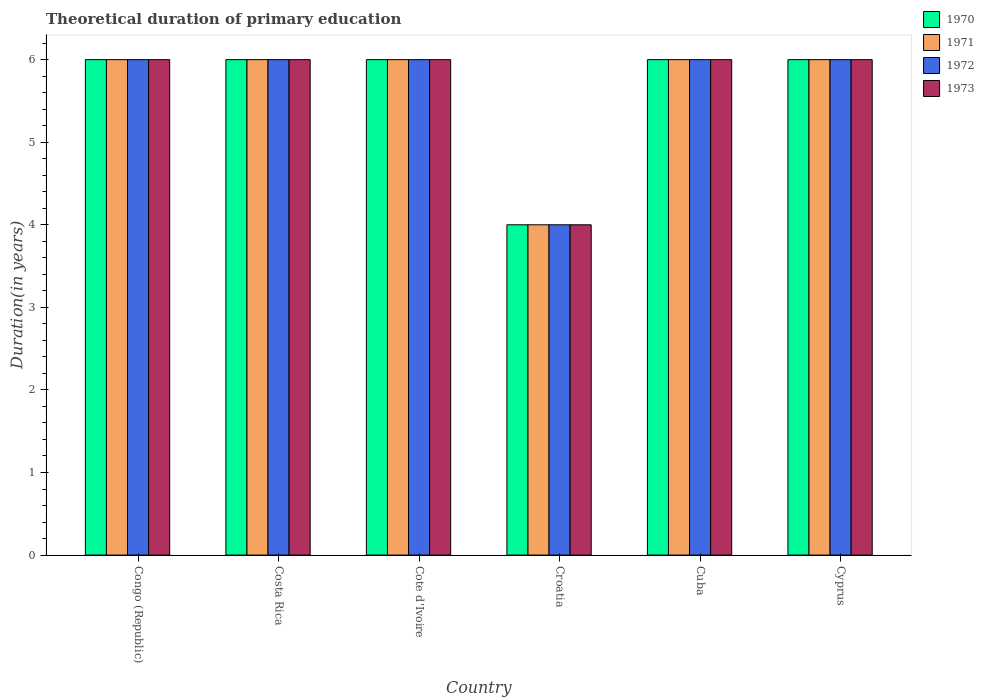How many different coloured bars are there?
Provide a short and direct response. 4. How many groups of bars are there?
Provide a short and direct response. 6. Are the number of bars on each tick of the X-axis equal?
Make the answer very short. Yes. How many bars are there on the 1st tick from the left?
Make the answer very short. 4. How many bars are there on the 2nd tick from the right?
Offer a terse response. 4. What is the label of the 3rd group of bars from the left?
Provide a succinct answer. Cote d'Ivoire. In how many cases, is the number of bars for a given country not equal to the number of legend labels?
Provide a succinct answer. 0. Across all countries, what is the minimum total theoretical duration of primary education in 1972?
Offer a very short reply. 4. In which country was the total theoretical duration of primary education in 1970 maximum?
Offer a terse response. Congo (Republic). In which country was the total theoretical duration of primary education in 1970 minimum?
Provide a short and direct response. Croatia. What is the total total theoretical duration of primary education in 1973 in the graph?
Provide a short and direct response. 34. What is the difference between the total theoretical duration of primary education in 1971 in Costa Rica and that in Cote d'Ivoire?
Provide a succinct answer. 0. What is the average total theoretical duration of primary education in 1973 per country?
Give a very brief answer. 5.67. What is the difference between the total theoretical duration of primary education of/in 1972 and total theoretical duration of primary education of/in 1970 in Croatia?
Offer a very short reply. 0. Is the total theoretical duration of primary education in 1973 in Costa Rica less than that in Croatia?
Your response must be concise. No. What is the difference between the highest and the lowest total theoretical duration of primary education in 1970?
Give a very brief answer. 2. In how many countries, is the total theoretical duration of primary education in 1973 greater than the average total theoretical duration of primary education in 1973 taken over all countries?
Your response must be concise. 5. Is the sum of the total theoretical duration of primary education in 1971 in Congo (Republic) and Cuba greater than the maximum total theoretical duration of primary education in 1973 across all countries?
Ensure brevity in your answer.  Yes. What does the 2nd bar from the left in Costa Rica represents?
Your answer should be very brief. 1971. How many bars are there?
Give a very brief answer. 24. How many countries are there in the graph?
Your answer should be very brief. 6. Does the graph contain any zero values?
Provide a short and direct response. No. How many legend labels are there?
Give a very brief answer. 4. How are the legend labels stacked?
Keep it short and to the point. Vertical. What is the title of the graph?
Your response must be concise. Theoretical duration of primary education. What is the label or title of the X-axis?
Make the answer very short. Country. What is the label or title of the Y-axis?
Keep it short and to the point. Duration(in years). What is the Duration(in years) of 1971 in Congo (Republic)?
Your answer should be compact. 6. What is the Duration(in years) of 1973 in Congo (Republic)?
Ensure brevity in your answer.  6. What is the Duration(in years) of 1970 in Costa Rica?
Keep it short and to the point. 6. What is the Duration(in years) of 1970 in Cote d'Ivoire?
Provide a succinct answer. 6. What is the Duration(in years) of 1971 in Cote d'Ivoire?
Provide a short and direct response. 6. What is the Duration(in years) in 1973 in Cote d'Ivoire?
Keep it short and to the point. 6. Across all countries, what is the maximum Duration(in years) of 1973?
Make the answer very short. 6. Across all countries, what is the minimum Duration(in years) of 1972?
Offer a terse response. 4. Across all countries, what is the minimum Duration(in years) in 1973?
Provide a short and direct response. 4. What is the total Duration(in years) in 1970 in the graph?
Your response must be concise. 34. What is the total Duration(in years) of 1971 in the graph?
Provide a succinct answer. 34. What is the total Duration(in years) of 1972 in the graph?
Provide a succinct answer. 34. What is the total Duration(in years) of 1973 in the graph?
Keep it short and to the point. 34. What is the difference between the Duration(in years) in 1971 in Congo (Republic) and that in Costa Rica?
Your response must be concise. 0. What is the difference between the Duration(in years) of 1972 in Congo (Republic) and that in Costa Rica?
Provide a succinct answer. 0. What is the difference between the Duration(in years) of 1970 in Congo (Republic) and that in Cote d'Ivoire?
Offer a terse response. 0. What is the difference between the Duration(in years) in 1971 in Congo (Republic) and that in Cote d'Ivoire?
Offer a very short reply. 0. What is the difference between the Duration(in years) in 1972 in Congo (Republic) and that in Cote d'Ivoire?
Keep it short and to the point. 0. What is the difference between the Duration(in years) in 1970 in Congo (Republic) and that in Croatia?
Provide a short and direct response. 2. What is the difference between the Duration(in years) in 1971 in Congo (Republic) and that in Croatia?
Make the answer very short. 2. What is the difference between the Duration(in years) in 1971 in Congo (Republic) and that in Cuba?
Offer a very short reply. 0. What is the difference between the Duration(in years) in 1972 in Congo (Republic) and that in Cuba?
Keep it short and to the point. 0. What is the difference between the Duration(in years) in 1973 in Congo (Republic) and that in Cuba?
Offer a very short reply. 0. What is the difference between the Duration(in years) of 1973 in Congo (Republic) and that in Cyprus?
Ensure brevity in your answer.  0. What is the difference between the Duration(in years) in 1970 in Costa Rica and that in Cote d'Ivoire?
Make the answer very short. 0. What is the difference between the Duration(in years) in 1971 in Costa Rica and that in Cote d'Ivoire?
Ensure brevity in your answer.  0. What is the difference between the Duration(in years) in 1972 in Costa Rica and that in Cote d'Ivoire?
Keep it short and to the point. 0. What is the difference between the Duration(in years) in 1973 in Costa Rica and that in Cote d'Ivoire?
Your answer should be compact. 0. What is the difference between the Duration(in years) in 1970 in Costa Rica and that in Croatia?
Your response must be concise. 2. What is the difference between the Duration(in years) of 1971 in Costa Rica and that in Croatia?
Offer a very short reply. 2. What is the difference between the Duration(in years) of 1973 in Costa Rica and that in Croatia?
Your answer should be very brief. 2. What is the difference between the Duration(in years) in 1971 in Costa Rica and that in Cuba?
Provide a short and direct response. 0. What is the difference between the Duration(in years) of 1972 in Costa Rica and that in Cuba?
Offer a very short reply. 0. What is the difference between the Duration(in years) in 1973 in Costa Rica and that in Cuba?
Provide a succinct answer. 0. What is the difference between the Duration(in years) of 1970 in Costa Rica and that in Cyprus?
Your answer should be compact. 0. What is the difference between the Duration(in years) of 1973 in Costa Rica and that in Cyprus?
Make the answer very short. 0. What is the difference between the Duration(in years) of 1971 in Cote d'Ivoire and that in Croatia?
Provide a succinct answer. 2. What is the difference between the Duration(in years) of 1972 in Cote d'Ivoire and that in Croatia?
Keep it short and to the point. 2. What is the difference between the Duration(in years) in 1970 in Cote d'Ivoire and that in Cuba?
Give a very brief answer. 0. What is the difference between the Duration(in years) of 1970 in Cote d'Ivoire and that in Cyprus?
Provide a succinct answer. 0. What is the difference between the Duration(in years) in 1971 in Cote d'Ivoire and that in Cyprus?
Keep it short and to the point. 0. What is the difference between the Duration(in years) in 1972 in Cote d'Ivoire and that in Cyprus?
Offer a terse response. 0. What is the difference between the Duration(in years) in 1970 in Croatia and that in Cuba?
Your answer should be compact. -2. What is the difference between the Duration(in years) of 1971 in Croatia and that in Cuba?
Give a very brief answer. -2. What is the difference between the Duration(in years) in 1973 in Croatia and that in Cuba?
Offer a terse response. -2. What is the difference between the Duration(in years) of 1971 in Croatia and that in Cyprus?
Offer a terse response. -2. What is the difference between the Duration(in years) in 1972 in Croatia and that in Cyprus?
Offer a very short reply. -2. What is the difference between the Duration(in years) in 1973 in Croatia and that in Cyprus?
Keep it short and to the point. -2. What is the difference between the Duration(in years) of 1970 in Cuba and that in Cyprus?
Offer a terse response. 0. What is the difference between the Duration(in years) of 1971 in Cuba and that in Cyprus?
Your response must be concise. 0. What is the difference between the Duration(in years) of 1972 in Cuba and that in Cyprus?
Offer a terse response. 0. What is the difference between the Duration(in years) in 1970 in Congo (Republic) and the Duration(in years) in 1971 in Costa Rica?
Your answer should be very brief. 0. What is the difference between the Duration(in years) in 1970 in Congo (Republic) and the Duration(in years) in 1972 in Costa Rica?
Give a very brief answer. 0. What is the difference between the Duration(in years) of 1970 in Congo (Republic) and the Duration(in years) of 1973 in Costa Rica?
Offer a terse response. 0. What is the difference between the Duration(in years) in 1971 in Congo (Republic) and the Duration(in years) in 1972 in Costa Rica?
Ensure brevity in your answer.  0. What is the difference between the Duration(in years) in 1970 in Congo (Republic) and the Duration(in years) in 1973 in Cote d'Ivoire?
Provide a succinct answer. 0. What is the difference between the Duration(in years) of 1971 in Congo (Republic) and the Duration(in years) of 1972 in Cote d'Ivoire?
Offer a terse response. 0. What is the difference between the Duration(in years) in 1971 in Congo (Republic) and the Duration(in years) in 1973 in Cote d'Ivoire?
Make the answer very short. 0. What is the difference between the Duration(in years) in 1972 in Congo (Republic) and the Duration(in years) in 1973 in Cote d'Ivoire?
Provide a short and direct response. 0. What is the difference between the Duration(in years) in 1970 in Congo (Republic) and the Duration(in years) in 1972 in Croatia?
Your answer should be compact. 2. What is the difference between the Duration(in years) of 1970 in Congo (Republic) and the Duration(in years) of 1973 in Croatia?
Keep it short and to the point. 2. What is the difference between the Duration(in years) of 1971 in Congo (Republic) and the Duration(in years) of 1973 in Croatia?
Your answer should be compact. 2. What is the difference between the Duration(in years) in 1970 in Congo (Republic) and the Duration(in years) in 1971 in Cuba?
Your response must be concise. 0. What is the difference between the Duration(in years) in 1970 in Congo (Republic) and the Duration(in years) in 1973 in Cuba?
Offer a very short reply. 0. What is the difference between the Duration(in years) in 1971 in Congo (Republic) and the Duration(in years) in 1972 in Cuba?
Make the answer very short. 0. What is the difference between the Duration(in years) of 1970 in Congo (Republic) and the Duration(in years) of 1973 in Cyprus?
Your answer should be very brief. 0. What is the difference between the Duration(in years) in 1972 in Congo (Republic) and the Duration(in years) in 1973 in Cyprus?
Provide a short and direct response. 0. What is the difference between the Duration(in years) in 1970 in Costa Rica and the Duration(in years) in 1971 in Cote d'Ivoire?
Your answer should be very brief. 0. What is the difference between the Duration(in years) of 1971 in Costa Rica and the Duration(in years) of 1972 in Cote d'Ivoire?
Give a very brief answer. 0. What is the difference between the Duration(in years) in 1970 in Costa Rica and the Duration(in years) in 1972 in Croatia?
Provide a short and direct response. 2. What is the difference between the Duration(in years) of 1971 in Costa Rica and the Duration(in years) of 1972 in Croatia?
Your answer should be compact. 2. What is the difference between the Duration(in years) of 1972 in Costa Rica and the Duration(in years) of 1973 in Croatia?
Make the answer very short. 2. What is the difference between the Duration(in years) in 1970 in Costa Rica and the Duration(in years) in 1971 in Cuba?
Ensure brevity in your answer.  0. What is the difference between the Duration(in years) in 1970 in Costa Rica and the Duration(in years) in 1972 in Cuba?
Your response must be concise. 0. What is the difference between the Duration(in years) of 1970 in Costa Rica and the Duration(in years) of 1973 in Cuba?
Your answer should be compact. 0. What is the difference between the Duration(in years) in 1972 in Costa Rica and the Duration(in years) in 1973 in Cuba?
Provide a short and direct response. 0. What is the difference between the Duration(in years) in 1970 in Costa Rica and the Duration(in years) in 1972 in Cyprus?
Keep it short and to the point. 0. What is the difference between the Duration(in years) of 1970 in Costa Rica and the Duration(in years) of 1973 in Cyprus?
Keep it short and to the point. 0. What is the difference between the Duration(in years) in 1971 in Costa Rica and the Duration(in years) in 1972 in Cyprus?
Ensure brevity in your answer.  0. What is the difference between the Duration(in years) in 1971 in Costa Rica and the Duration(in years) in 1973 in Cyprus?
Your answer should be compact. 0. What is the difference between the Duration(in years) in 1970 in Cote d'Ivoire and the Duration(in years) in 1972 in Croatia?
Your answer should be very brief. 2. What is the difference between the Duration(in years) of 1970 in Cote d'Ivoire and the Duration(in years) of 1973 in Croatia?
Provide a short and direct response. 2. What is the difference between the Duration(in years) of 1971 in Cote d'Ivoire and the Duration(in years) of 1973 in Croatia?
Offer a terse response. 2. What is the difference between the Duration(in years) of 1970 in Cote d'Ivoire and the Duration(in years) of 1971 in Cuba?
Give a very brief answer. 0. What is the difference between the Duration(in years) of 1971 in Cote d'Ivoire and the Duration(in years) of 1972 in Cuba?
Make the answer very short. 0. What is the difference between the Duration(in years) of 1971 in Cote d'Ivoire and the Duration(in years) of 1973 in Cuba?
Provide a short and direct response. 0. What is the difference between the Duration(in years) in 1972 in Cote d'Ivoire and the Duration(in years) in 1973 in Cuba?
Provide a short and direct response. 0. What is the difference between the Duration(in years) of 1970 in Cote d'Ivoire and the Duration(in years) of 1972 in Cyprus?
Offer a terse response. 0. What is the difference between the Duration(in years) in 1970 in Cote d'Ivoire and the Duration(in years) in 1973 in Cyprus?
Your response must be concise. 0. What is the difference between the Duration(in years) of 1971 in Cote d'Ivoire and the Duration(in years) of 1972 in Cyprus?
Provide a succinct answer. 0. What is the difference between the Duration(in years) of 1972 in Cote d'Ivoire and the Duration(in years) of 1973 in Cyprus?
Your response must be concise. 0. What is the difference between the Duration(in years) in 1970 in Croatia and the Duration(in years) in 1971 in Cuba?
Your response must be concise. -2. What is the difference between the Duration(in years) in 1970 in Croatia and the Duration(in years) in 1972 in Cuba?
Offer a very short reply. -2. What is the difference between the Duration(in years) in 1970 in Croatia and the Duration(in years) in 1973 in Cuba?
Ensure brevity in your answer.  -2. What is the difference between the Duration(in years) of 1972 in Croatia and the Duration(in years) of 1973 in Cuba?
Your answer should be compact. -2. What is the difference between the Duration(in years) in 1970 in Croatia and the Duration(in years) in 1973 in Cyprus?
Give a very brief answer. -2. What is the difference between the Duration(in years) in 1972 in Croatia and the Duration(in years) in 1973 in Cyprus?
Provide a short and direct response. -2. What is the difference between the Duration(in years) of 1970 in Cuba and the Duration(in years) of 1972 in Cyprus?
Offer a terse response. 0. What is the difference between the Duration(in years) in 1971 in Cuba and the Duration(in years) in 1973 in Cyprus?
Make the answer very short. 0. What is the difference between the Duration(in years) of 1972 in Cuba and the Duration(in years) of 1973 in Cyprus?
Make the answer very short. 0. What is the average Duration(in years) in 1970 per country?
Give a very brief answer. 5.67. What is the average Duration(in years) of 1971 per country?
Make the answer very short. 5.67. What is the average Duration(in years) in 1972 per country?
Offer a very short reply. 5.67. What is the average Duration(in years) in 1973 per country?
Ensure brevity in your answer.  5.67. What is the difference between the Duration(in years) in 1970 and Duration(in years) in 1971 in Congo (Republic)?
Your answer should be very brief. 0. What is the difference between the Duration(in years) in 1970 and Duration(in years) in 1972 in Congo (Republic)?
Offer a terse response. 0. What is the difference between the Duration(in years) in 1971 and Duration(in years) in 1972 in Congo (Republic)?
Offer a very short reply. 0. What is the difference between the Duration(in years) in 1971 and Duration(in years) in 1973 in Congo (Republic)?
Your response must be concise. 0. What is the difference between the Duration(in years) in 1972 and Duration(in years) in 1973 in Congo (Republic)?
Offer a very short reply. 0. What is the difference between the Duration(in years) in 1970 and Duration(in years) in 1973 in Costa Rica?
Make the answer very short. 0. What is the difference between the Duration(in years) in 1971 and Duration(in years) in 1973 in Costa Rica?
Make the answer very short. 0. What is the difference between the Duration(in years) of 1970 and Duration(in years) of 1973 in Cote d'Ivoire?
Your answer should be compact. 0. What is the difference between the Duration(in years) of 1971 and Duration(in years) of 1972 in Cote d'Ivoire?
Offer a terse response. 0. What is the difference between the Duration(in years) of 1971 and Duration(in years) of 1973 in Cote d'Ivoire?
Your answer should be compact. 0. What is the difference between the Duration(in years) of 1972 and Duration(in years) of 1973 in Cote d'Ivoire?
Offer a very short reply. 0. What is the difference between the Duration(in years) of 1970 and Duration(in years) of 1971 in Croatia?
Your answer should be compact. 0. What is the difference between the Duration(in years) of 1970 and Duration(in years) of 1973 in Croatia?
Offer a very short reply. 0. What is the difference between the Duration(in years) of 1970 and Duration(in years) of 1971 in Cuba?
Provide a succinct answer. 0. What is the difference between the Duration(in years) in 1970 and Duration(in years) in 1972 in Cuba?
Offer a very short reply. 0. What is the difference between the Duration(in years) of 1970 and Duration(in years) of 1973 in Cuba?
Make the answer very short. 0. What is the difference between the Duration(in years) in 1970 and Duration(in years) in 1972 in Cyprus?
Make the answer very short. 0. What is the difference between the Duration(in years) in 1971 and Duration(in years) in 1972 in Cyprus?
Offer a terse response. 0. What is the difference between the Duration(in years) in 1971 and Duration(in years) in 1973 in Cyprus?
Your response must be concise. 0. What is the difference between the Duration(in years) in 1972 and Duration(in years) in 1973 in Cyprus?
Keep it short and to the point. 0. What is the ratio of the Duration(in years) in 1970 in Congo (Republic) to that in Costa Rica?
Offer a terse response. 1. What is the ratio of the Duration(in years) in 1972 in Congo (Republic) to that in Costa Rica?
Your answer should be compact. 1. What is the ratio of the Duration(in years) in 1973 in Congo (Republic) to that in Costa Rica?
Provide a succinct answer. 1. What is the ratio of the Duration(in years) of 1971 in Congo (Republic) to that in Cote d'Ivoire?
Make the answer very short. 1. What is the ratio of the Duration(in years) of 1970 in Congo (Republic) to that in Croatia?
Your response must be concise. 1.5. What is the ratio of the Duration(in years) in 1973 in Congo (Republic) to that in Croatia?
Your answer should be very brief. 1.5. What is the ratio of the Duration(in years) in 1970 in Congo (Republic) to that in Cuba?
Offer a terse response. 1. What is the ratio of the Duration(in years) of 1971 in Congo (Republic) to that in Cuba?
Keep it short and to the point. 1. What is the ratio of the Duration(in years) of 1972 in Congo (Republic) to that in Cuba?
Keep it short and to the point. 1. What is the ratio of the Duration(in years) in 1973 in Congo (Republic) to that in Cuba?
Provide a succinct answer. 1. What is the ratio of the Duration(in years) in 1973 in Congo (Republic) to that in Cyprus?
Make the answer very short. 1. What is the ratio of the Duration(in years) in 1970 in Costa Rica to that in Cote d'Ivoire?
Give a very brief answer. 1. What is the ratio of the Duration(in years) of 1971 in Costa Rica to that in Cote d'Ivoire?
Make the answer very short. 1. What is the ratio of the Duration(in years) of 1971 in Costa Rica to that in Croatia?
Your response must be concise. 1.5. What is the ratio of the Duration(in years) in 1973 in Costa Rica to that in Croatia?
Offer a very short reply. 1.5. What is the ratio of the Duration(in years) in 1970 in Costa Rica to that in Cuba?
Ensure brevity in your answer.  1. What is the ratio of the Duration(in years) of 1972 in Costa Rica to that in Cuba?
Keep it short and to the point. 1. What is the ratio of the Duration(in years) of 1970 in Costa Rica to that in Cyprus?
Make the answer very short. 1. What is the ratio of the Duration(in years) in 1973 in Costa Rica to that in Cyprus?
Your answer should be very brief. 1. What is the ratio of the Duration(in years) in 1971 in Cote d'Ivoire to that in Croatia?
Your answer should be very brief. 1.5. What is the ratio of the Duration(in years) in 1970 in Cote d'Ivoire to that in Cuba?
Provide a short and direct response. 1. What is the ratio of the Duration(in years) in 1972 in Cote d'Ivoire to that in Cuba?
Your answer should be compact. 1. What is the ratio of the Duration(in years) in 1971 in Cote d'Ivoire to that in Cyprus?
Give a very brief answer. 1. What is the ratio of the Duration(in years) of 1972 in Cote d'Ivoire to that in Cyprus?
Make the answer very short. 1. What is the ratio of the Duration(in years) in 1973 in Cote d'Ivoire to that in Cyprus?
Give a very brief answer. 1. What is the ratio of the Duration(in years) of 1973 in Croatia to that in Cuba?
Your response must be concise. 0.67. What is the ratio of the Duration(in years) in 1970 in Croatia to that in Cyprus?
Ensure brevity in your answer.  0.67. What is the ratio of the Duration(in years) in 1971 in Croatia to that in Cyprus?
Offer a terse response. 0.67. What is the ratio of the Duration(in years) of 1972 in Croatia to that in Cyprus?
Provide a short and direct response. 0.67. What is the ratio of the Duration(in years) of 1973 in Croatia to that in Cyprus?
Make the answer very short. 0.67. What is the ratio of the Duration(in years) in 1972 in Cuba to that in Cyprus?
Keep it short and to the point. 1. What is the ratio of the Duration(in years) in 1973 in Cuba to that in Cyprus?
Your answer should be compact. 1. What is the difference between the highest and the second highest Duration(in years) of 1973?
Provide a short and direct response. 0. What is the difference between the highest and the lowest Duration(in years) in 1970?
Offer a terse response. 2. 